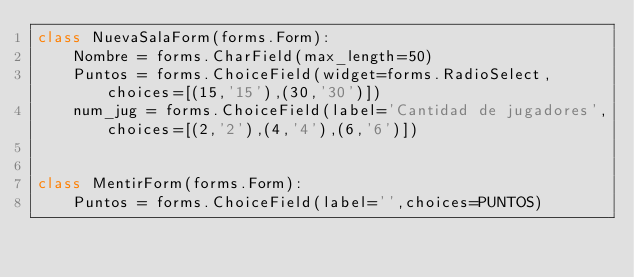Convert code to text. <code><loc_0><loc_0><loc_500><loc_500><_Python_>class NuevaSalaForm(forms.Form):
    Nombre = forms.CharField(max_length=50)
    Puntos = forms.ChoiceField(widget=forms.RadioSelect,choices=[(15,'15'),(30,'30')])
    num_jug = forms.ChoiceField(label='Cantidad de jugadores',choices=[(2,'2'),(4,'4'),(6,'6')])


class MentirForm(forms.Form):
    Puntos = forms.ChoiceField(label='',choices=PUNTOS)</code> 